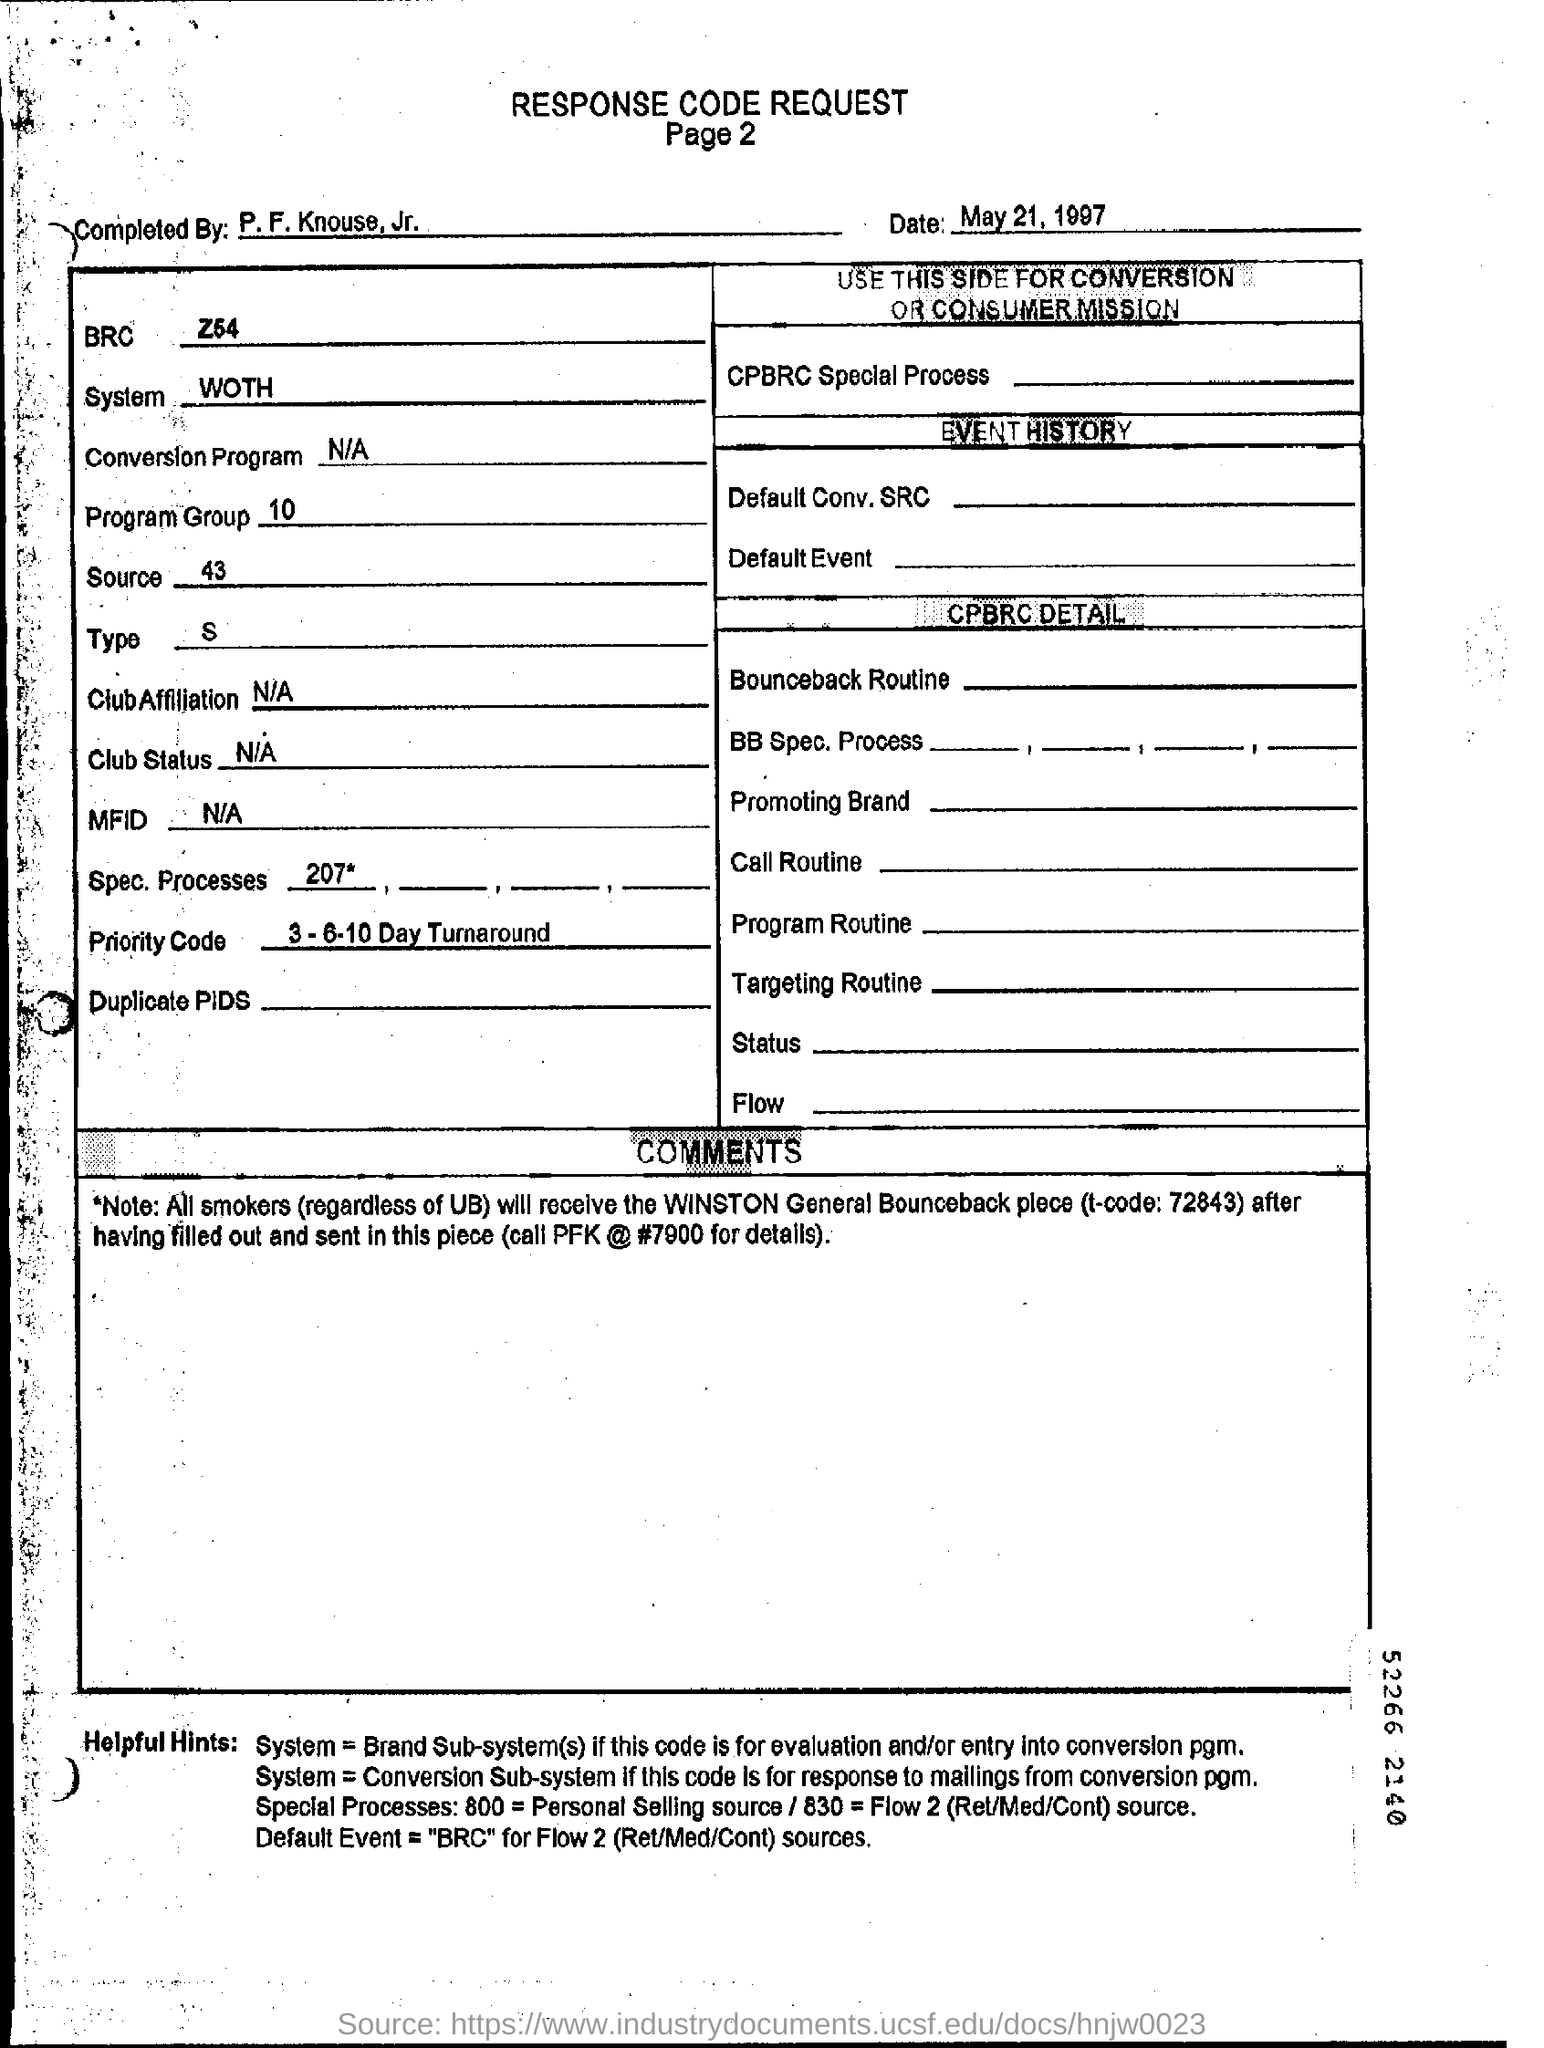Indicate a few pertinent items in this graphic. The priority code is 3-6-10 day turnaround. The date in the response code request form is May 21, 1997. 